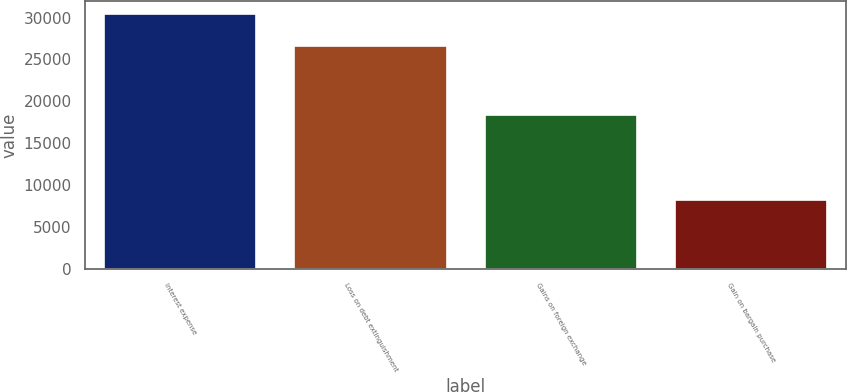<chart> <loc_0><loc_0><loc_500><loc_500><bar_chart><fcel>Interest expense<fcel>Loss on debt extinguishment<fcel>Gains on foreign exchange<fcel>Gain on bargain purchase<nl><fcel>30403<fcel>26650<fcel>18342<fcel>8207<nl></chart> 